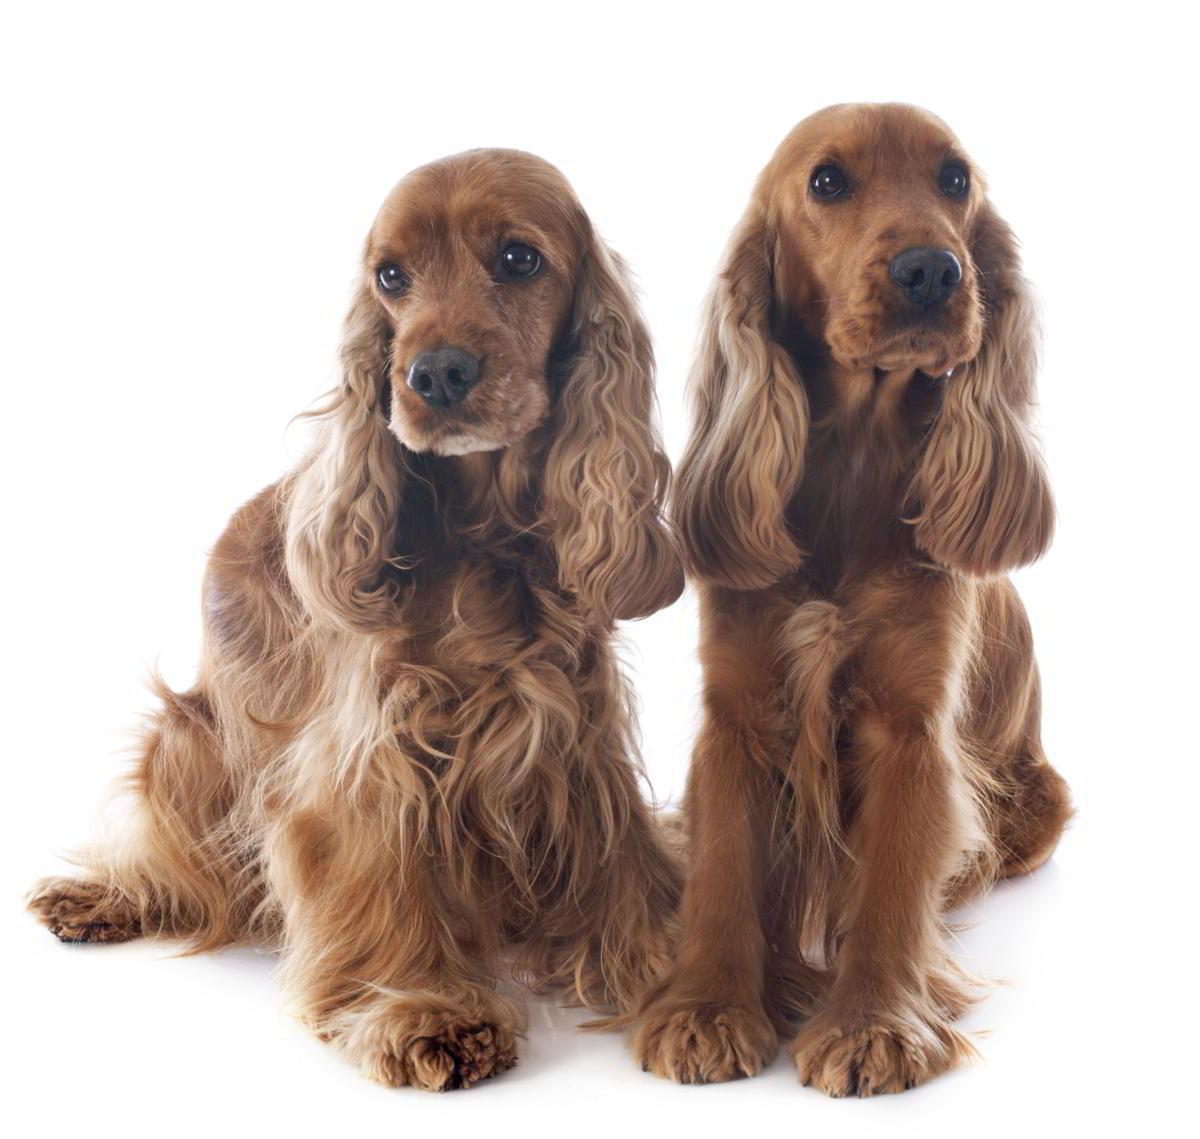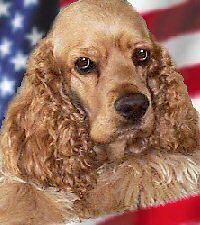The first image is the image on the left, the second image is the image on the right. For the images displayed, is the sentence "The dog in the image on the right is outside on the grass." factually correct? Answer yes or no. No. The first image is the image on the left, the second image is the image on the right. Given the left and right images, does the statement "The left image includes exactly twice as many spaniel dogs as the right image." hold true? Answer yes or no. Yes. 